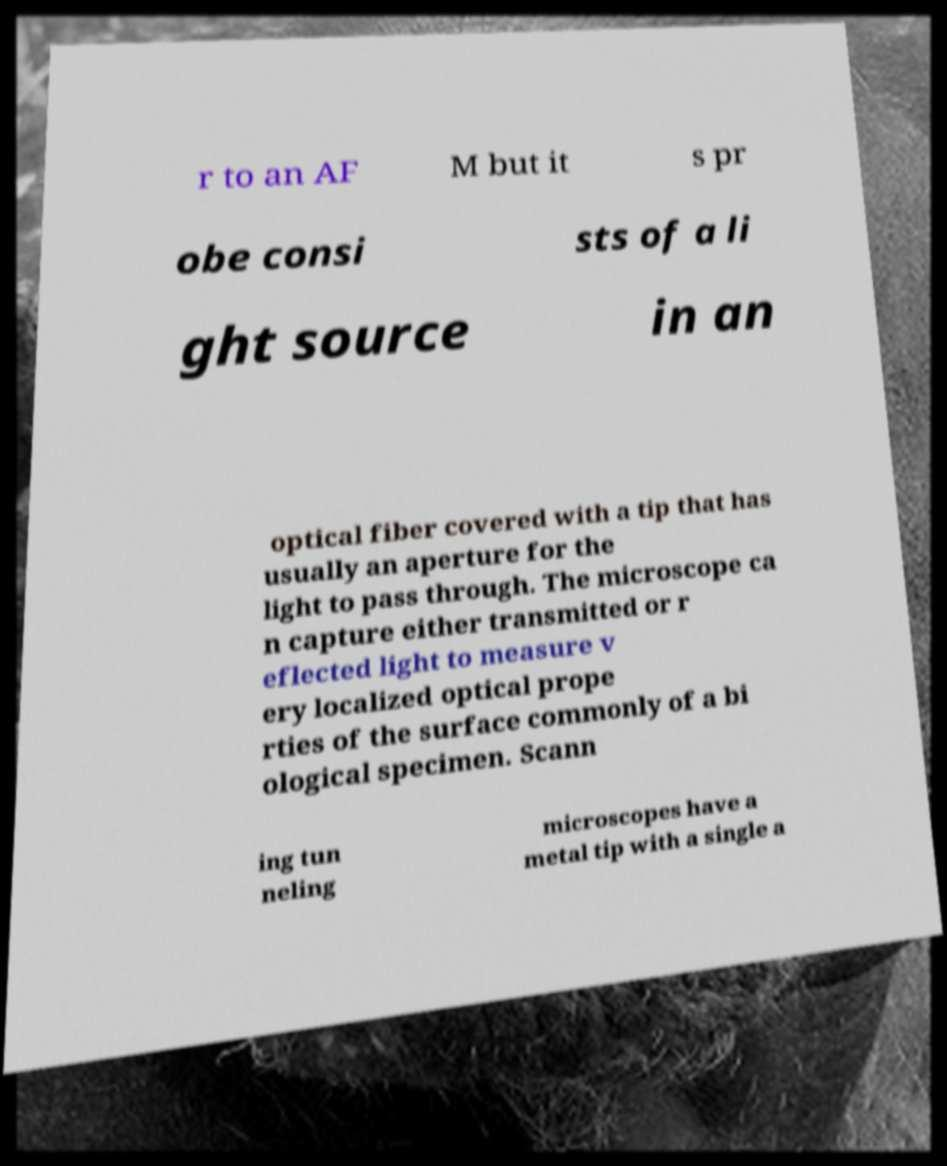For documentation purposes, I need the text within this image transcribed. Could you provide that? r to an AF M but it s pr obe consi sts of a li ght source in an optical fiber covered with a tip that has usually an aperture for the light to pass through. The microscope ca n capture either transmitted or r eflected light to measure v ery localized optical prope rties of the surface commonly of a bi ological specimen. Scann ing tun neling microscopes have a metal tip with a single a 